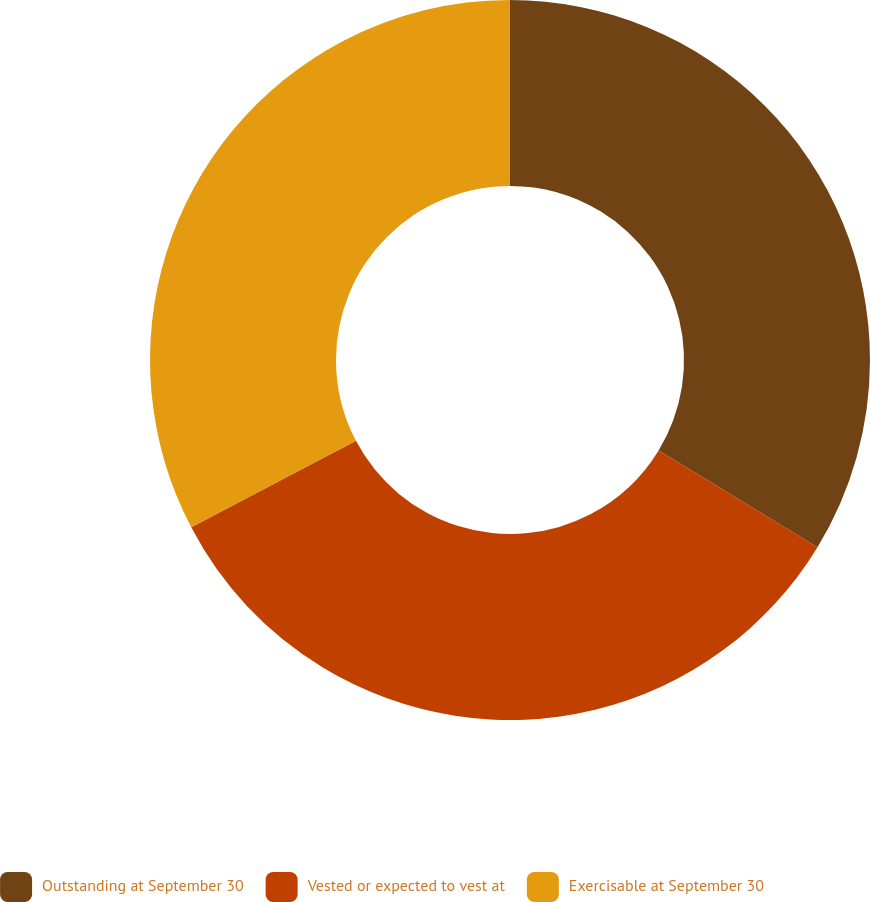<chart> <loc_0><loc_0><loc_500><loc_500><pie_chart><fcel>Outstanding at September 30<fcel>Vested or expected to vest at<fcel>Exercisable at September 30<nl><fcel>33.7%<fcel>33.6%<fcel>32.69%<nl></chart> 